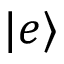<formula> <loc_0><loc_0><loc_500><loc_500>| e \rangle</formula> 